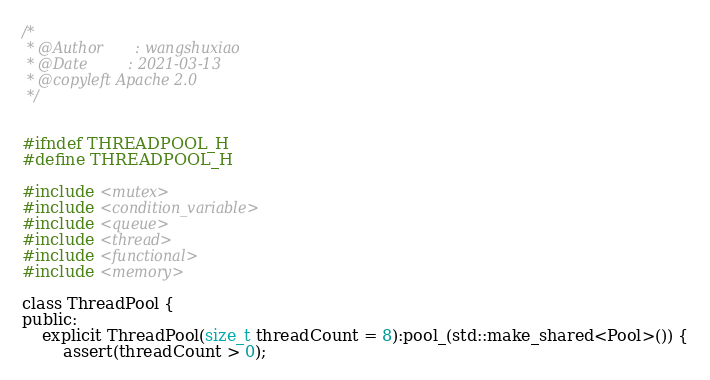Convert code to text. <code><loc_0><loc_0><loc_500><loc_500><_C_>/*
 * @Author       : wangshuxiao
 * @Date         : 2021-03-13
 * @copyleft Apache 2.0
 */


#ifndef THREADPOOL_H
#define THREADPOOL_H

#include <mutex>
#include <condition_variable>
#include <queue>
#include <thread>
#include <functional>
#include <memory>

class ThreadPool {
public:
    explicit ThreadPool(size_t threadCount = 8):pool_(std::make_shared<Pool>()) {
        assert(threadCount > 0);</code> 